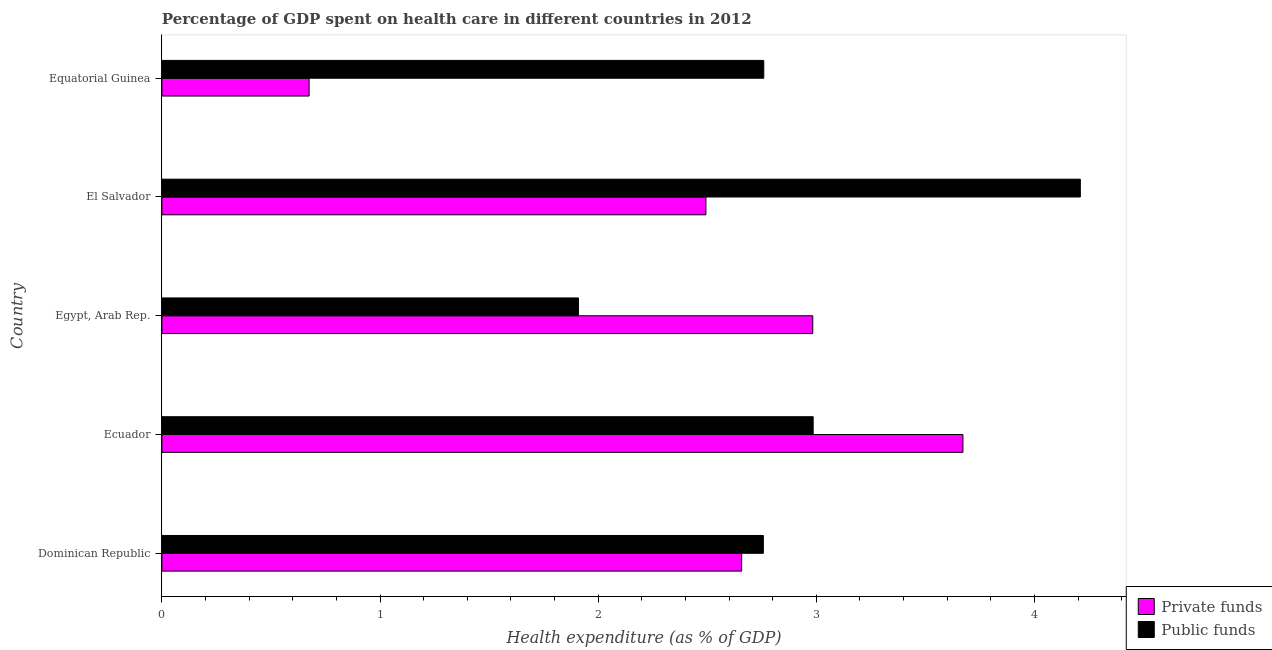How many different coloured bars are there?
Your answer should be very brief. 2. How many groups of bars are there?
Your answer should be compact. 5. How many bars are there on the 1st tick from the bottom?
Your response must be concise. 2. What is the label of the 3rd group of bars from the top?
Provide a succinct answer. Egypt, Arab Rep. What is the amount of private funds spent in healthcare in Ecuador?
Offer a very short reply. 3.67. Across all countries, what is the maximum amount of private funds spent in healthcare?
Make the answer very short. 3.67. Across all countries, what is the minimum amount of public funds spent in healthcare?
Offer a terse response. 1.91. In which country was the amount of public funds spent in healthcare maximum?
Your answer should be very brief. El Salvador. In which country was the amount of private funds spent in healthcare minimum?
Keep it short and to the point. Equatorial Guinea. What is the total amount of public funds spent in healthcare in the graph?
Provide a short and direct response. 14.62. What is the difference between the amount of private funds spent in healthcare in El Salvador and that in Equatorial Guinea?
Ensure brevity in your answer.  1.82. What is the difference between the amount of private funds spent in healthcare in Equatorial Guinea and the amount of public funds spent in healthcare in Dominican Republic?
Your response must be concise. -2.08. What is the average amount of private funds spent in healthcare per country?
Keep it short and to the point. 2.5. What is the difference between the amount of private funds spent in healthcare and amount of public funds spent in healthcare in El Salvador?
Your answer should be very brief. -1.72. Is the amount of public funds spent in healthcare in Dominican Republic less than that in Egypt, Arab Rep.?
Give a very brief answer. No. Is the difference between the amount of public funds spent in healthcare in Egypt, Arab Rep. and El Salvador greater than the difference between the amount of private funds spent in healthcare in Egypt, Arab Rep. and El Salvador?
Offer a terse response. No. What is the difference between the highest and the second highest amount of private funds spent in healthcare?
Offer a terse response. 0.69. Is the sum of the amount of private funds spent in healthcare in Ecuador and Egypt, Arab Rep. greater than the maximum amount of public funds spent in healthcare across all countries?
Offer a very short reply. Yes. What does the 2nd bar from the top in Ecuador represents?
Provide a short and direct response. Private funds. What does the 1st bar from the bottom in Ecuador represents?
Provide a succinct answer. Private funds. How many bars are there?
Offer a very short reply. 10. What is the difference between two consecutive major ticks on the X-axis?
Your response must be concise. 1. Where does the legend appear in the graph?
Offer a terse response. Bottom right. How many legend labels are there?
Provide a succinct answer. 2. How are the legend labels stacked?
Provide a short and direct response. Vertical. What is the title of the graph?
Your answer should be very brief. Percentage of GDP spent on health care in different countries in 2012. What is the label or title of the X-axis?
Keep it short and to the point. Health expenditure (as % of GDP). What is the label or title of the Y-axis?
Your answer should be very brief. Country. What is the Health expenditure (as % of GDP) of Private funds in Dominican Republic?
Your answer should be compact. 2.66. What is the Health expenditure (as % of GDP) in Public funds in Dominican Republic?
Your response must be concise. 2.76. What is the Health expenditure (as % of GDP) of Private funds in Ecuador?
Your response must be concise. 3.67. What is the Health expenditure (as % of GDP) of Public funds in Ecuador?
Offer a very short reply. 2.99. What is the Health expenditure (as % of GDP) in Private funds in Egypt, Arab Rep.?
Ensure brevity in your answer.  2.98. What is the Health expenditure (as % of GDP) of Public funds in Egypt, Arab Rep.?
Keep it short and to the point. 1.91. What is the Health expenditure (as % of GDP) of Private funds in El Salvador?
Ensure brevity in your answer.  2.49. What is the Health expenditure (as % of GDP) in Public funds in El Salvador?
Ensure brevity in your answer.  4.21. What is the Health expenditure (as % of GDP) in Private funds in Equatorial Guinea?
Offer a terse response. 0.67. What is the Health expenditure (as % of GDP) of Public funds in Equatorial Guinea?
Provide a succinct answer. 2.76. Across all countries, what is the maximum Health expenditure (as % of GDP) in Private funds?
Your response must be concise. 3.67. Across all countries, what is the maximum Health expenditure (as % of GDP) in Public funds?
Make the answer very short. 4.21. Across all countries, what is the minimum Health expenditure (as % of GDP) of Private funds?
Provide a short and direct response. 0.67. Across all countries, what is the minimum Health expenditure (as % of GDP) in Public funds?
Your answer should be very brief. 1.91. What is the total Health expenditure (as % of GDP) of Private funds in the graph?
Make the answer very short. 12.48. What is the total Health expenditure (as % of GDP) of Public funds in the graph?
Provide a short and direct response. 14.62. What is the difference between the Health expenditure (as % of GDP) of Private funds in Dominican Republic and that in Ecuador?
Offer a very short reply. -1.01. What is the difference between the Health expenditure (as % of GDP) in Public funds in Dominican Republic and that in Ecuador?
Offer a terse response. -0.23. What is the difference between the Health expenditure (as % of GDP) of Private funds in Dominican Republic and that in Egypt, Arab Rep.?
Your answer should be compact. -0.33. What is the difference between the Health expenditure (as % of GDP) in Public funds in Dominican Republic and that in Egypt, Arab Rep.?
Offer a terse response. 0.85. What is the difference between the Health expenditure (as % of GDP) of Private funds in Dominican Republic and that in El Salvador?
Your answer should be very brief. 0.16. What is the difference between the Health expenditure (as % of GDP) in Public funds in Dominican Republic and that in El Salvador?
Make the answer very short. -1.45. What is the difference between the Health expenditure (as % of GDP) in Private funds in Dominican Republic and that in Equatorial Guinea?
Your answer should be very brief. 1.98. What is the difference between the Health expenditure (as % of GDP) of Public funds in Dominican Republic and that in Equatorial Guinea?
Provide a short and direct response. -0. What is the difference between the Health expenditure (as % of GDP) of Private funds in Ecuador and that in Egypt, Arab Rep.?
Your response must be concise. 0.69. What is the difference between the Health expenditure (as % of GDP) of Public funds in Ecuador and that in Egypt, Arab Rep.?
Give a very brief answer. 1.08. What is the difference between the Health expenditure (as % of GDP) in Private funds in Ecuador and that in El Salvador?
Your response must be concise. 1.18. What is the difference between the Health expenditure (as % of GDP) of Public funds in Ecuador and that in El Salvador?
Provide a succinct answer. -1.22. What is the difference between the Health expenditure (as % of GDP) in Private funds in Ecuador and that in Equatorial Guinea?
Offer a terse response. 3. What is the difference between the Health expenditure (as % of GDP) of Public funds in Ecuador and that in Equatorial Guinea?
Make the answer very short. 0.23. What is the difference between the Health expenditure (as % of GDP) of Private funds in Egypt, Arab Rep. and that in El Salvador?
Make the answer very short. 0.49. What is the difference between the Health expenditure (as % of GDP) in Public funds in Egypt, Arab Rep. and that in El Salvador?
Make the answer very short. -2.3. What is the difference between the Health expenditure (as % of GDP) of Private funds in Egypt, Arab Rep. and that in Equatorial Guinea?
Make the answer very short. 2.31. What is the difference between the Health expenditure (as % of GDP) of Public funds in Egypt, Arab Rep. and that in Equatorial Guinea?
Give a very brief answer. -0.85. What is the difference between the Health expenditure (as % of GDP) of Private funds in El Salvador and that in Equatorial Guinea?
Keep it short and to the point. 1.82. What is the difference between the Health expenditure (as % of GDP) of Public funds in El Salvador and that in Equatorial Guinea?
Keep it short and to the point. 1.45. What is the difference between the Health expenditure (as % of GDP) in Private funds in Dominican Republic and the Health expenditure (as % of GDP) in Public funds in Ecuador?
Give a very brief answer. -0.33. What is the difference between the Health expenditure (as % of GDP) in Private funds in Dominican Republic and the Health expenditure (as % of GDP) in Public funds in Egypt, Arab Rep.?
Your answer should be compact. 0.75. What is the difference between the Health expenditure (as % of GDP) in Private funds in Dominican Republic and the Health expenditure (as % of GDP) in Public funds in El Salvador?
Give a very brief answer. -1.55. What is the difference between the Health expenditure (as % of GDP) of Private funds in Dominican Republic and the Health expenditure (as % of GDP) of Public funds in Equatorial Guinea?
Keep it short and to the point. -0.1. What is the difference between the Health expenditure (as % of GDP) in Private funds in Ecuador and the Health expenditure (as % of GDP) in Public funds in Egypt, Arab Rep.?
Ensure brevity in your answer.  1.76. What is the difference between the Health expenditure (as % of GDP) in Private funds in Ecuador and the Health expenditure (as % of GDP) in Public funds in El Salvador?
Provide a short and direct response. -0.54. What is the difference between the Health expenditure (as % of GDP) of Private funds in Ecuador and the Health expenditure (as % of GDP) of Public funds in Equatorial Guinea?
Your answer should be very brief. 0.91. What is the difference between the Health expenditure (as % of GDP) of Private funds in Egypt, Arab Rep. and the Health expenditure (as % of GDP) of Public funds in El Salvador?
Provide a succinct answer. -1.23. What is the difference between the Health expenditure (as % of GDP) in Private funds in Egypt, Arab Rep. and the Health expenditure (as % of GDP) in Public funds in Equatorial Guinea?
Keep it short and to the point. 0.22. What is the difference between the Health expenditure (as % of GDP) in Private funds in El Salvador and the Health expenditure (as % of GDP) in Public funds in Equatorial Guinea?
Provide a short and direct response. -0.27. What is the average Health expenditure (as % of GDP) in Private funds per country?
Ensure brevity in your answer.  2.5. What is the average Health expenditure (as % of GDP) in Public funds per country?
Your answer should be compact. 2.92. What is the difference between the Health expenditure (as % of GDP) in Private funds and Health expenditure (as % of GDP) in Public funds in Dominican Republic?
Your answer should be compact. -0.1. What is the difference between the Health expenditure (as % of GDP) of Private funds and Health expenditure (as % of GDP) of Public funds in Ecuador?
Provide a short and direct response. 0.69. What is the difference between the Health expenditure (as % of GDP) of Private funds and Health expenditure (as % of GDP) of Public funds in Egypt, Arab Rep.?
Make the answer very short. 1.07. What is the difference between the Health expenditure (as % of GDP) in Private funds and Health expenditure (as % of GDP) in Public funds in El Salvador?
Your answer should be very brief. -1.72. What is the difference between the Health expenditure (as % of GDP) of Private funds and Health expenditure (as % of GDP) of Public funds in Equatorial Guinea?
Keep it short and to the point. -2.08. What is the ratio of the Health expenditure (as % of GDP) in Private funds in Dominican Republic to that in Ecuador?
Ensure brevity in your answer.  0.72. What is the ratio of the Health expenditure (as % of GDP) in Public funds in Dominican Republic to that in Ecuador?
Make the answer very short. 0.92. What is the ratio of the Health expenditure (as % of GDP) in Private funds in Dominican Republic to that in Egypt, Arab Rep.?
Provide a short and direct response. 0.89. What is the ratio of the Health expenditure (as % of GDP) in Public funds in Dominican Republic to that in Egypt, Arab Rep.?
Provide a short and direct response. 1.44. What is the ratio of the Health expenditure (as % of GDP) of Private funds in Dominican Republic to that in El Salvador?
Provide a short and direct response. 1.07. What is the ratio of the Health expenditure (as % of GDP) in Public funds in Dominican Republic to that in El Salvador?
Ensure brevity in your answer.  0.65. What is the ratio of the Health expenditure (as % of GDP) of Private funds in Dominican Republic to that in Equatorial Guinea?
Offer a terse response. 3.94. What is the ratio of the Health expenditure (as % of GDP) in Public funds in Dominican Republic to that in Equatorial Guinea?
Your response must be concise. 1. What is the ratio of the Health expenditure (as % of GDP) in Private funds in Ecuador to that in Egypt, Arab Rep.?
Make the answer very short. 1.23. What is the ratio of the Health expenditure (as % of GDP) in Public funds in Ecuador to that in Egypt, Arab Rep.?
Make the answer very short. 1.56. What is the ratio of the Health expenditure (as % of GDP) of Private funds in Ecuador to that in El Salvador?
Offer a terse response. 1.47. What is the ratio of the Health expenditure (as % of GDP) in Public funds in Ecuador to that in El Salvador?
Provide a succinct answer. 0.71. What is the ratio of the Health expenditure (as % of GDP) in Private funds in Ecuador to that in Equatorial Guinea?
Your answer should be compact. 5.44. What is the ratio of the Health expenditure (as % of GDP) in Public funds in Ecuador to that in Equatorial Guinea?
Offer a terse response. 1.08. What is the ratio of the Health expenditure (as % of GDP) of Private funds in Egypt, Arab Rep. to that in El Salvador?
Offer a very short reply. 1.2. What is the ratio of the Health expenditure (as % of GDP) of Public funds in Egypt, Arab Rep. to that in El Salvador?
Provide a succinct answer. 0.45. What is the ratio of the Health expenditure (as % of GDP) in Private funds in Egypt, Arab Rep. to that in Equatorial Guinea?
Offer a very short reply. 4.42. What is the ratio of the Health expenditure (as % of GDP) of Public funds in Egypt, Arab Rep. to that in Equatorial Guinea?
Your response must be concise. 0.69. What is the ratio of the Health expenditure (as % of GDP) of Private funds in El Salvador to that in Equatorial Guinea?
Provide a short and direct response. 3.7. What is the ratio of the Health expenditure (as % of GDP) in Public funds in El Salvador to that in Equatorial Guinea?
Ensure brevity in your answer.  1.53. What is the difference between the highest and the second highest Health expenditure (as % of GDP) of Private funds?
Give a very brief answer. 0.69. What is the difference between the highest and the second highest Health expenditure (as % of GDP) of Public funds?
Make the answer very short. 1.22. What is the difference between the highest and the lowest Health expenditure (as % of GDP) in Private funds?
Keep it short and to the point. 3. What is the difference between the highest and the lowest Health expenditure (as % of GDP) in Public funds?
Make the answer very short. 2.3. 